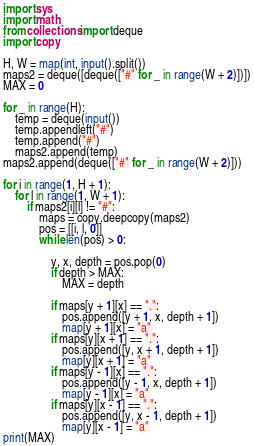Convert code to text. <code><loc_0><loc_0><loc_500><loc_500><_Python_>import sys
import math
from collections import deque
import copy

H, W = map(int, input().split())
maps2 = deque([deque(["#" for _ in range(W + 2)])])
MAX = 0

for _ in range(H):
    temp = deque(input())
    temp.appendleft("#")
    temp.append("#")
    maps2.append(temp)
maps2.append(deque(["#" for _ in range(W + 2)]))

for i in range(1, H + 1):
    for l in range(1, W + 1):
        if maps2[i][l] != "#":
            maps = copy.deepcopy(maps2)
            pos = [[i, l, 0]]
            while len(pos) > 0:

                y, x, depth = pos.pop(0)
                if depth > MAX:
                    MAX = depth

                if maps[y + 1][x] == ".":
                    pos.append([y + 1, x, depth + 1])
                    map[y + 1][x] = "a"
                if maps[y][x + 1] == ".":
                    pos.append([y, x + 1, depth + 1])
                    map[y][x + 1] = "a"
                if maps[y - 1][x] == ".":
                    pos.append([y - 1, x, depth + 1])
                    map[y - 1][x] = "a"
                if maps[y][x - 1] == ".":
                    pos.append([y, x - 1, depth + 1])
                    map[y][x - 1] = "a"
print(MAX)
</code> 